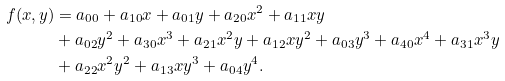Convert formula to latex. <formula><loc_0><loc_0><loc_500><loc_500>f ( x , y ) & = a _ { 0 0 } + a _ { 1 0 } x + a _ { 0 1 } y + a _ { 2 0 } x ^ { 2 } + a _ { 1 1 } x y \\ & + a _ { 0 2 } y ^ { 2 } + a _ { 3 0 } x ^ { 3 } + a _ { 2 1 } x ^ { 2 } y + a _ { 1 2 } x y ^ { 2 } + a _ { 0 3 } y ^ { 3 } + a _ { 4 0 } x ^ { 4 } + a _ { 3 1 } x ^ { 3 } y \\ & + a _ { 2 2 } x ^ { 2 } y ^ { 2 } + a _ { 1 3 } x y ^ { 3 } + a _ { 0 4 } y ^ { 4 } .</formula> 